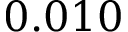Convert formula to latex. <formula><loc_0><loc_0><loc_500><loc_500>0 . 0 1 0</formula> 